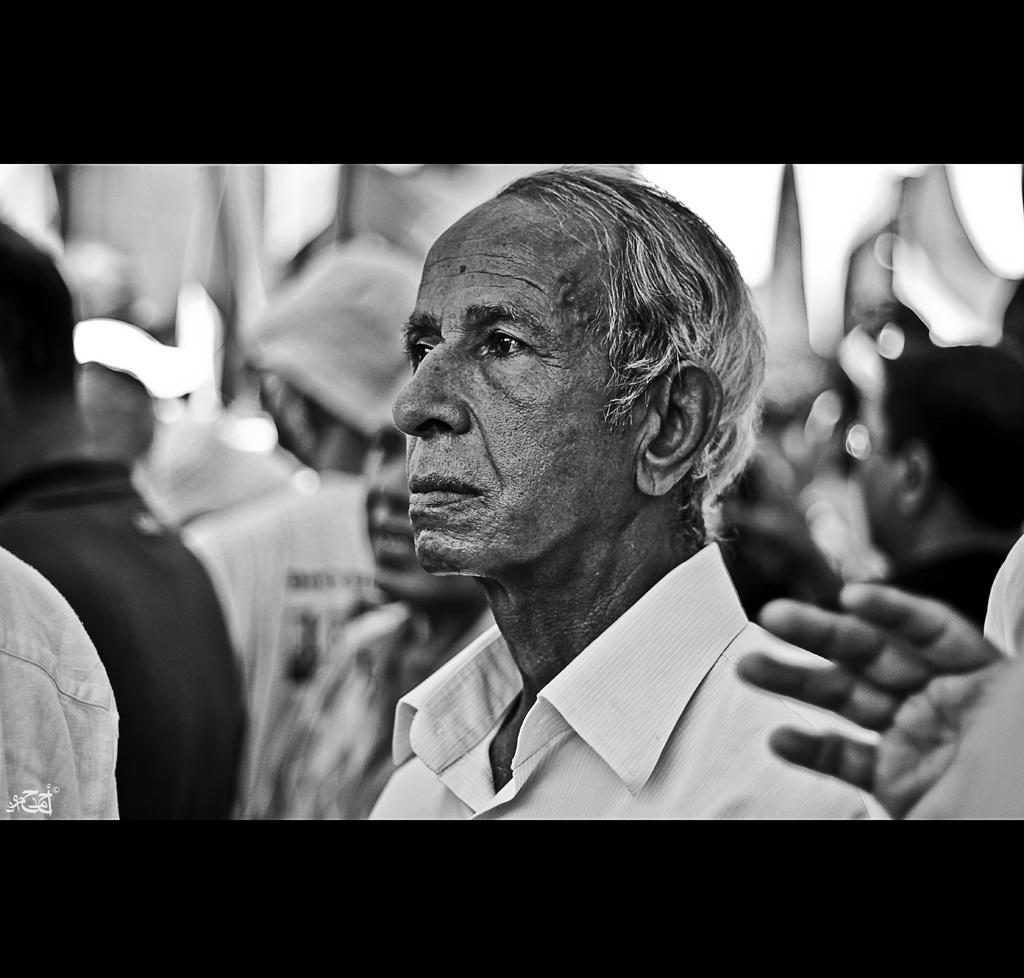What is the main subject of the image? There is a person in the image. What color scheme is used in the image? The image is in black and white. Can you describe the background of the image? The background is blurred. How many vases are visible in the image? There are no vases present in the image. What date is marked on the calendar in the image? There is no calendar present in the image. 